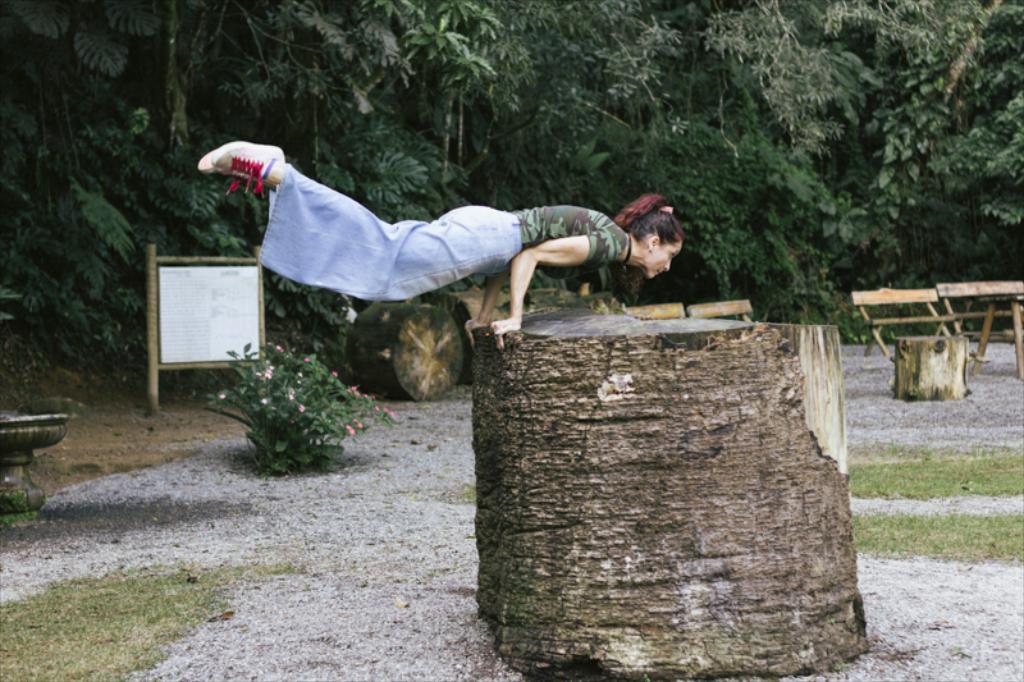Please provide a concise description of this image. The woman in the middle of the picture is exercising. Beside her, we see a wooden block. At the bottom of the picture, we see grass. On the left side, we see a planter and a plant which has pink and white flowers. Behind that, we see a white board with some text written on it. On the right side, we see a wooden block and wooden benches. There are trees in the background. 